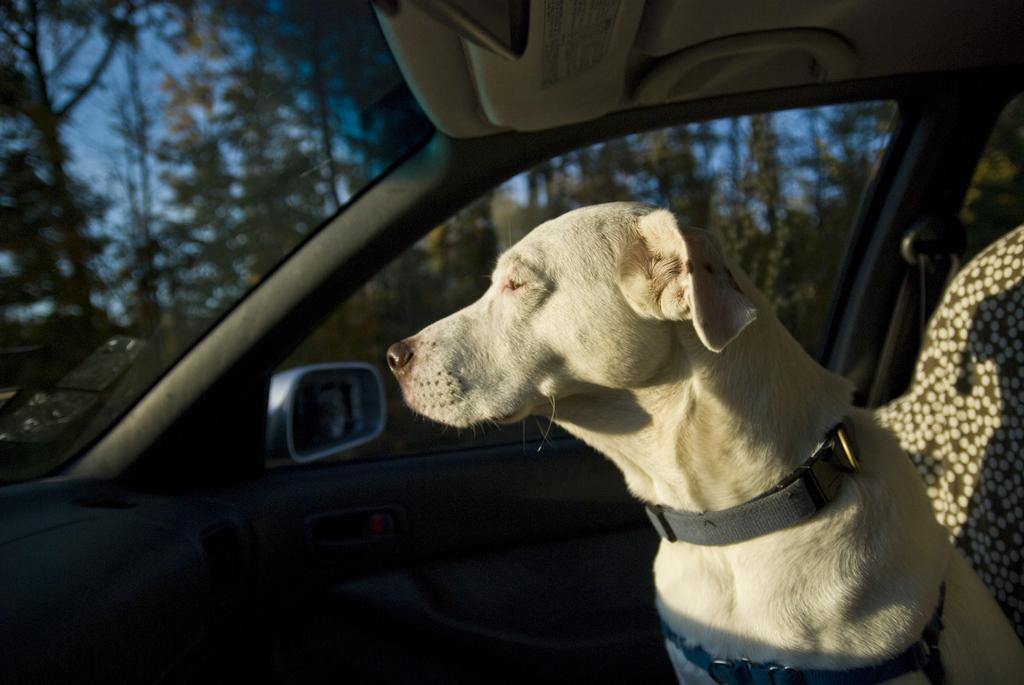What type of animal is present in the image? There is a dog in the image. Where is the dog located in the image? The dog is sitting in a car. What type of plate is visible on the dog's head in the image? There is no plate visible on the dog's head in the image. 